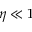Convert formula to latex. <formula><loc_0><loc_0><loc_500><loc_500>\eta \ll 1</formula> 